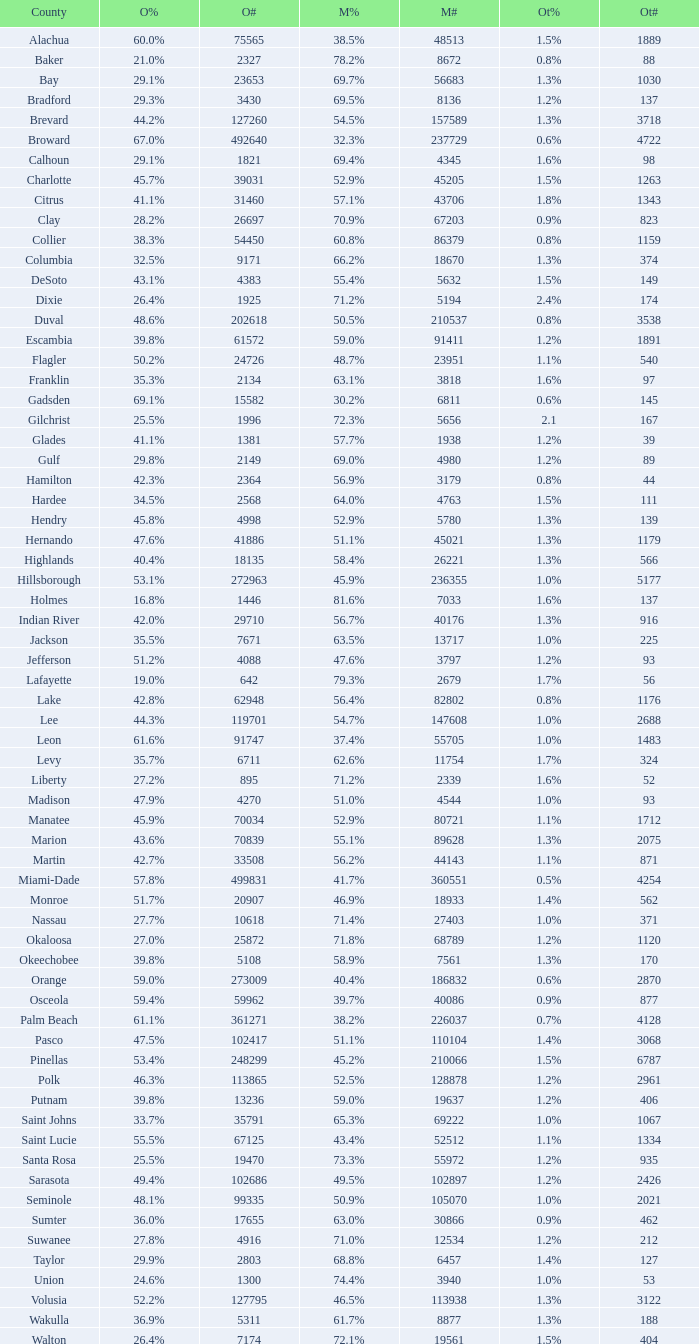9% and fewer than 4520 1.3%. 